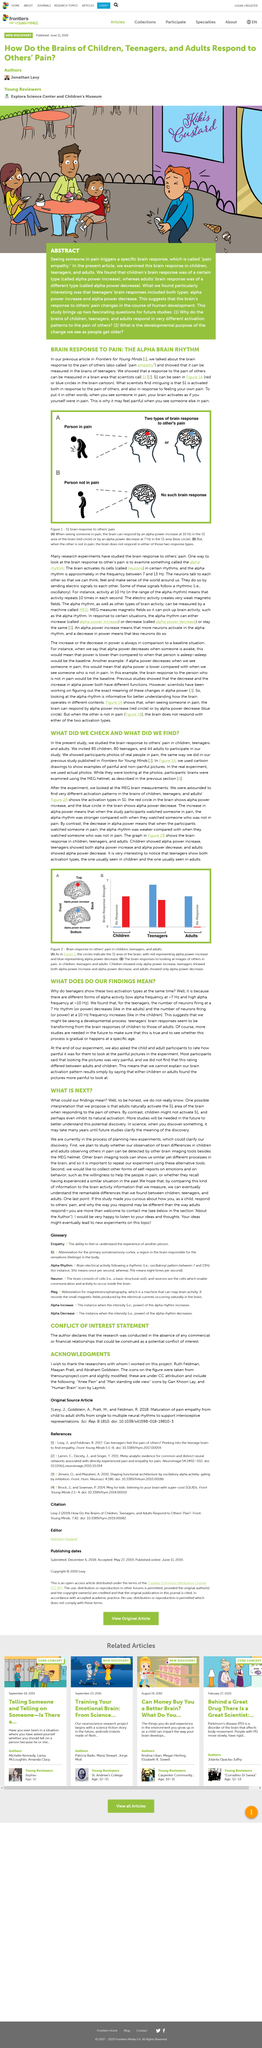Highlight a few significant elements in this photo. The increase of alpha power means that more neurons activate in the alpha rhythm, resulting in an increase in brain activity in the 8-12 Hz frequency range. Forty-four adults were invited. Eighty teenagers were invited. In science, the clarification of the meaning of a discovery may take many years. In the previous article, we discussed the brain's response to the pain of others. 